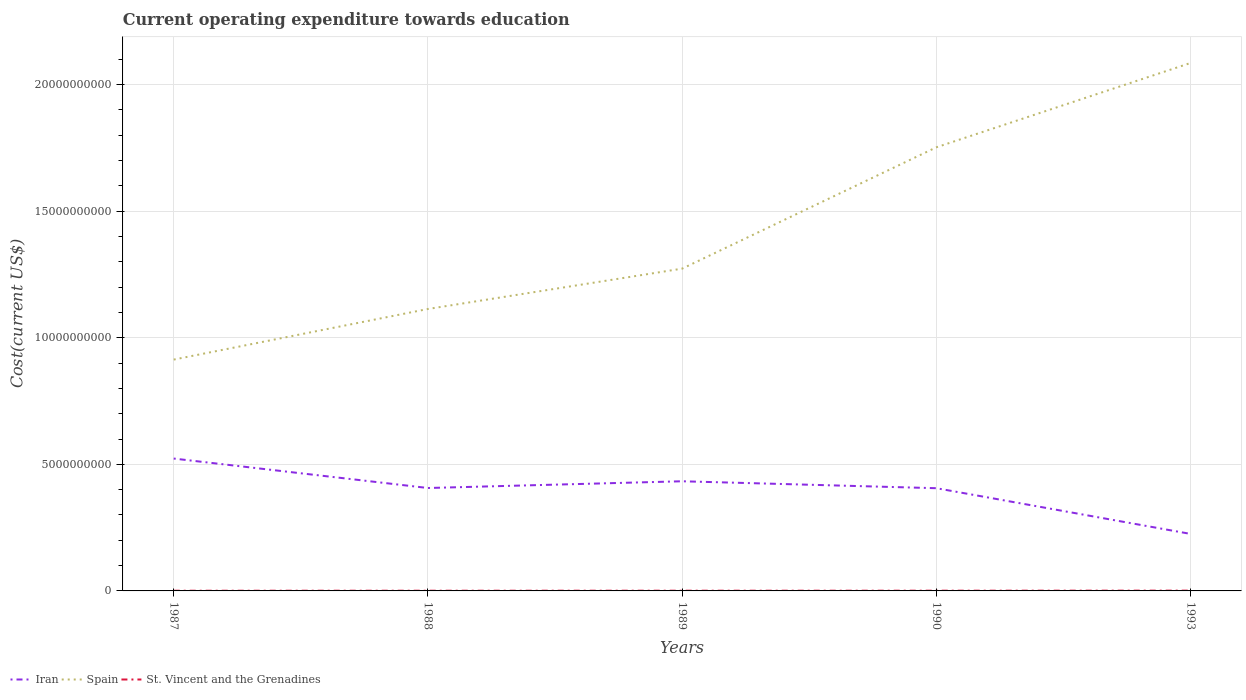How many different coloured lines are there?
Provide a short and direct response. 3. Does the line corresponding to Iran intersect with the line corresponding to St. Vincent and the Grenadines?
Provide a short and direct response. No. Across all years, what is the maximum expenditure towards education in Iran?
Provide a short and direct response. 2.25e+09. What is the total expenditure towards education in Spain in the graph?
Your answer should be compact. -4.79e+09. What is the difference between the highest and the second highest expenditure towards education in St. Vincent and the Grenadines?
Make the answer very short. 3.82e+06. What is the difference between the highest and the lowest expenditure towards education in Spain?
Your answer should be compact. 2. How many lines are there?
Offer a very short reply. 3. How many years are there in the graph?
Give a very brief answer. 5. Are the values on the major ticks of Y-axis written in scientific E-notation?
Offer a terse response. No. Does the graph contain grids?
Your response must be concise. Yes. How many legend labels are there?
Ensure brevity in your answer.  3. How are the legend labels stacked?
Make the answer very short. Horizontal. What is the title of the graph?
Give a very brief answer. Current operating expenditure towards education. Does "Korea (Democratic)" appear as one of the legend labels in the graph?
Offer a terse response. No. What is the label or title of the X-axis?
Ensure brevity in your answer.  Years. What is the label or title of the Y-axis?
Your response must be concise. Cost(current US$). What is the Cost(current US$) of Iran in 1987?
Your answer should be very brief. 5.23e+09. What is the Cost(current US$) of Spain in 1987?
Make the answer very short. 9.14e+09. What is the Cost(current US$) in St. Vincent and the Grenadines in 1987?
Your response must be concise. 7.44e+06. What is the Cost(current US$) in Iran in 1988?
Your answer should be very brief. 4.07e+09. What is the Cost(current US$) of Spain in 1988?
Ensure brevity in your answer.  1.11e+1. What is the Cost(current US$) of St. Vincent and the Grenadines in 1988?
Offer a terse response. 8.13e+06. What is the Cost(current US$) in Iran in 1989?
Offer a terse response. 4.33e+09. What is the Cost(current US$) of Spain in 1989?
Your answer should be compact. 1.27e+1. What is the Cost(current US$) in St. Vincent and the Grenadines in 1989?
Keep it short and to the point. 8.53e+06. What is the Cost(current US$) of Iran in 1990?
Your response must be concise. 4.06e+09. What is the Cost(current US$) of Spain in 1990?
Your response must be concise. 1.75e+1. What is the Cost(current US$) in St. Vincent and the Grenadines in 1990?
Make the answer very short. 8.99e+06. What is the Cost(current US$) in Iran in 1993?
Make the answer very short. 2.25e+09. What is the Cost(current US$) of Spain in 1993?
Ensure brevity in your answer.  2.09e+1. What is the Cost(current US$) of St. Vincent and the Grenadines in 1993?
Ensure brevity in your answer.  1.13e+07. Across all years, what is the maximum Cost(current US$) in Iran?
Provide a short and direct response. 5.23e+09. Across all years, what is the maximum Cost(current US$) in Spain?
Offer a very short reply. 2.09e+1. Across all years, what is the maximum Cost(current US$) in St. Vincent and the Grenadines?
Give a very brief answer. 1.13e+07. Across all years, what is the minimum Cost(current US$) of Iran?
Offer a terse response. 2.25e+09. Across all years, what is the minimum Cost(current US$) in Spain?
Provide a succinct answer. 9.14e+09. Across all years, what is the minimum Cost(current US$) of St. Vincent and the Grenadines?
Ensure brevity in your answer.  7.44e+06. What is the total Cost(current US$) in Iran in the graph?
Ensure brevity in your answer.  1.99e+1. What is the total Cost(current US$) in Spain in the graph?
Keep it short and to the point. 7.14e+1. What is the total Cost(current US$) in St. Vincent and the Grenadines in the graph?
Make the answer very short. 4.43e+07. What is the difference between the Cost(current US$) in Iran in 1987 and that in 1988?
Your answer should be compact. 1.16e+09. What is the difference between the Cost(current US$) in Spain in 1987 and that in 1988?
Keep it short and to the point. -2.00e+09. What is the difference between the Cost(current US$) in St. Vincent and the Grenadines in 1987 and that in 1988?
Make the answer very short. -6.94e+05. What is the difference between the Cost(current US$) of Iran in 1987 and that in 1989?
Keep it short and to the point. 8.97e+08. What is the difference between the Cost(current US$) in Spain in 1987 and that in 1989?
Your answer should be compact. -3.59e+09. What is the difference between the Cost(current US$) of St. Vincent and the Grenadines in 1987 and that in 1989?
Your response must be concise. -1.09e+06. What is the difference between the Cost(current US$) in Iran in 1987 and that in 1990?
Keep it short and to the point. 1.17e+09. What is the difference between the Cost(current US$) in Spain in 1987 and that in 1990?
Ensure brevity in your answer.  -8.39e+09. What is the difference between the Cost(current US$) of St. Vincent and the Grenadines in 1987 and that in 1990?
Your response must be concise. -1.55e+06. What is the difference between the Cost(current US$) of Iran in 1987 and that in 1993?
Offer a terse response. 2.98e+09. What is the difference between the Cost(current US$) of Spain in 1987 and that in 1993?
Ensure brevity in your answer.  -1.17e+1. What is the difference between the Cost(current US$) of St. Vincent and the Grenadines in 1987 and that in 1993?
Make the answer very short. -3.82e+06. What is the difference between the Cost(current US$) in Iran in 1988 and that in 1989?
Your response must be concise. -2.66e+08. What is the difference between the Cost(current US$) in Spain in 1988 and that in 1989?
Your answer should be compact. -1.59e+09. What is the difference between the Cost(current US$) in St. Vincent and the Grenadines in 1988 and that in 1989?
Offer a terse response. -3.98e+05. What is the difference between the Cost(current US$) of Iran in 1988 and that in 1990?
Offer a very short reply. 8.02e+06. What is the difference between the Cost(current US$) of Spain in 1988 and that in 1990?
Keep it short and to the point. -6.39e+09. What is the difference between the Cost(current US$) in St. Vincent and the Grenadines in 1988 and that in 1990?
Your answer should be very brief. -8.57e+05. What is the difference between the Cost(current US$) of Iran in 1988 and that in 1993?
Offer a terse response. 1.81e+09. What is the difference between the Cost(current US$) in Spain in 1988 and that in 1993?
Keep it short and to the point. -9.72e+09. What is the difference between the Cost(current US$) of St. Vincent and the Grenadines in 1988 and that in 1993?
Provide a succinct answer. -3.13e+06. What is the difference between the Cost(current US$) in Iran in 1989 and that in 1990?
Provide a succinct answer. 2.74e+08. What is the difference between the Cost(current US$) in Spain in 1989 and that in 1990?
Ensure brevity in your answer.  -4.79e+09. What is the difference between the Cost(current US$) in St. Vincent and the Grenadines in 1989 and that in 1990?
Your answer should be very brief. -4.59e+05. What is the difference between the Cost(current US$) of Iran in 1989 and that in 1993?
Ensure brevity in your answer.  2.08e+09. What is the difference between the Cost(current US$) of Spain in 1989 and that in 1993?
Give a very brief answer. -8.12e+09. What is the difference between the Cost(current US$) of St. Vincent and the Grenadines in 1989 and that in 1993?
Your response must be concise. -2.73e+06. What is the difference between the Cost(current US$) in Iran in 1990 and that in 1993?
Your response must be concise. 1.81e+09. What is the difference between the Cost(current US$) of Spain in 1990 and that in 1993?
Ensure brevity in your answer.  -3.33e+09. What is the difference between the Cost(current US$) of St. Vincent and the Grenadines in 1990 and that in 1993?
Offer a very short reply. -2.27e+06. What is the difference between the Cost(current US$) of Iran in 1987 and the Cost(current US$) of Spain in 1988?
Provide a short and direct response. -5.91e+09. What is the difference between the Cost(current US$) of Iran in 1987 and the Cost(current US$) of St. Vincent and the Grenadines in 1988?
Ensure brevity in your answer.  5.22e+09. What is the difference between the Cost(current US$) of Spain in 1987 and the Cost(current US$) of St. Vincent and the Grenadines in 1988?
Provide a succinct answer. 9.13e+09. What is the difference between the Cost(current US$) of Iran in 1987 and the Cost(current US$) of Spain in 1989?
Keep it short and to the point. -7.50e+09. What is the difference between the Cost(current US$) in Iran in 1987 and the Cost(current US$) in St. Vincent and the Grenadines in 1989?
Keep it short and to the point. 5.22e+09. What is the difference between the Cost(current US$) of Spain in 1987 and the Cost(current US$) of St. Vincent and the Grenadines in 1989?
Offer a very short reply. 9.13e+09. What is the difference between the Cost(current US$) of Iran in 1987 and the Cost(current US$) of Spain in 1990?
Ensure brevity in your answer.  -1.23e+1. What is the difference between the Cost(current US$) in Iran in 1987 and the Cost(current US$) in St. Vincent and the Grenadines in 1990?
Your response must be concise. 5.22e+09. What is the difference between the Cost(current US$) in Spain in 1987 and the Cost(current US$) in St. Vincent and the Grenadines in 1990?
Your answer should be very brief. 9.13e+09. What is the difference between the Cost(current US$) in Iran in 1987 and the Cost(current US$) in Spain in 1993?
Your answer should be very brief. -1.56e+1. What is the difference between the Cost(current US$) in Iran in 1987 and the Cost(current US$) in St. Vincent and the Grenadines in 1993?
Your answer should be compact. 5.22e+09. What is the difference between the Cost(current US$) in Spain in 1987 and the Cost(current US$) in St. Vincent and the Grenadines in 1993?
Provide a short and direct response. 9.13e+09. What is the difference between the Cost(current US$) of Iran in 1988 and the Cost(current US$) of Spain in 1989?
Provide a succinct answer. -8.67e+09. What is the difference between the Cost(current US$) in Iran in 1988 and the Cost(current US$) in St. Vincent and the Grenadines in 1989?
Provide a short and direct response. 4.06e+09. What is the difference between the Cost(current US$) of Spain in 1988 and the Cost(current US$) of St. Vincent and the Grenadines in 1989?
Make the answer very short. 1.11e+1. What is the difference between the Cost(current US$) in Iran in 1988 and the Cost(current US$) in Spain in 1990?
Keep it short and to the point. -1.35e+1. What is the difference between the Cost(current US$) of Iran in 1988 and the Cost(current US$) of St. Vincent and the Grenadines in 1990?
Your answer should be very brief. 4.06e+09. What is the difference between the Cost(current US$) of Spain in 1988 and the Cost(current US$) of St. Vincent and the Grenadines in 1990?
Ensure brevity in your answer.  1.11e+1. What is the difference between the Cost(current US$) of Iran in 1988 and the Cost(current US$) of Spain in 1993?
Offer a very short reply. -1.68e+1. What is the difference between the Cost(current US$) in Iran in 1988 and the Cost(current US$) in St. Vincent and the Grenadines in 1993?
Offer a very short reply. 4.05e+09. What is the difference between the Cost(current US$) of Spain in 1988 and the Cost(current US$) of St. Vincent and the Grenadines in 1993?
Your response must be concise. 1.11e+1. What is the difference between the Cost(current US$) of Iran in 1989 and the Cost(current US$) of Spain in 1990?
Your response must be concise. -1.32e+1. What is the difference between the Cost(current US$) in Iran in 1989 and the Cost(current US$) in St. Vincent and the Grenadines in 1990?
Provide a succinct answer. 4.32e+09. What is the difference between the Cost(current US$) in Spain in 1989 and the Cost(current US$) in St. Vincent and the Grenadines in 1990?
Your answer should be very brief. 1.27e+1. What is the difference between the Cost(current US$) of Iran in 1989 and the Cost(current US$) of Spain in 1993?
Offer a terse response. -1.65e+1. What is the difference between the Cost(current US$) of Iran in 1989 and the Cost(current US$) of St. Vincent and the Grenadines in 1993?
Offer a very short reply. 4.32e+09. What is the difference between the Cost(current US$) of Spain in 1989 and the Cost(current US$) of St. Vincent and the Grenadines in 1993?
Your answer should be very brief. 1.27e+1. What is the difference between the Cost(current US$) in Iran in 1990 and the Cost(current US$) in Spain in 1993?
Offer a very short reply. -1.68e+1. What is the difference between the Cost(current US$) in Iran in 1990 and the Cost(current US$) in St. Vincent and the Grenadines in 1993?
Give a very brief answer. 4.05e+09. What is the difference between the Cost(current US$) of Spain in 1990 and the Cost(current US$) of St. Vincent and the Grenadines in 1993?
Give a very brief answer. 1.75e+1. What is the average Cost(current US$) in Iran per year?
Offer a terse response. 3.99e+09. What is the average Cost(current US$) in Spain per year?
Give a very brief answer. 1.43e+1. What is the average Cost(current US$) of St. Vincent and the Grenadines per year?
Your response must be concise. 8.87e+06. In the year 1987, what is the difference between the Cost(current US$) in Iran and Cost(current US$) in Spain?
Your response must be concise. -3.91e+09. In the year 1987, what is the difference between the Cost(current US$) in Iran and Cost(current US$) in St. Vincent and the Grenadines?
Offer a terse response. 5.22e+09. In the year 1987, what is the difference between the Cost(current US$) of Spain and Cost(current US$) of St. Vincent and the Grenadines?
Your answer should be very brief. 9.13e+09. In the year 1988, what is the difference between the Cost(current US$) of Iran and Cost(current US$) of Spain?
Provide a short and direct response. -7.07e+09. In the year 1988, what is the difference between the Cost(current US$) in Iran and Cost(current US$) in St. Vincent and the Grenadines?
Ensure brevity in your answer.  4.06e+09. In the year 1988, what is the difference between the Cost(current US$) of Spain and Cost(current US$) of St. Vincent and the Grenadines?
Make the answer very short. 1.11e+1. In the year 1989, what is the difference between the Cost(current US$) in Iran and Cost(current US$) in Spain?
Keep it short and to the point. -8.40e+09. In the year 1989, what is the difference between the Cost(current US$) of Iran and Cost(current US$) of St. Vincent and the Grenadines?
Your response must be concise. 4.32e+09. In the year 1989, what is the difference between the Cost(current US$) in Spain and Cost(current US$) in St. Vincent and the Grenadines?
Your answer should be very brief. 1.27e+1. In the year 1990, what is the difference between the Cost(current US$) in Iran and Cost(current US$) in Spain?
Provide a short and direct response. -1.35e+1. In the year 1990, what is the difference between the Cost(current US$) in Iran and Cost(current US$) in St. Vincent and the Grenadines?
Provide a short and direct response. 4.05e+09. In the year 1990, what is the difference between the Cost(current US$) of Spain and Cost(current US$) of St. Vincent and the Grenadines?
Make the answer very short. 1.75e+1. In the year 1993, what is the difference between the Cost(current US$) of Iran and Cost(current US$) of Spain?
Your response must be concise. -1.86e+1. In the year 1993, what is the difference between the Cost(current US$) of Iran and Cost(current US$) of St. Vincent and the Grenadines?
Give a very brief answer. 2.24e+09. In the year 1993, what is the difference between the Cost(current US$) in Spain and Cost(current US$) in St. Vincent and the Grenadines?
Provide a short and direct response. 2.08e+1. What is the ratio of the Cost(current US$) in Iran in 1987 to that in 1988?
Ensure brevity in your answer.  1.29. What is the ratio of the Cost(current US$) of Spain in 1987 to that in 1988?
Keep it short and to the point. 0.82. What is the ratio of the Cost(current US$) in St. Vincent and the Grenadines in 1987 to that in 1988?
Provide a short and direct response. 0.91. What is the ratio of the Cost(current US$) of Iran in 1987 to that in 1989?
Provide a short and direct response. 1.21. What is the ratio of the Cost(current US$) of Spain in 1987 to that in 1989?
Keep it short and to the point. 0.72. What is the ratio of the Cost(current US$) in St. Vincent and the Grenadines in 1987 to that in 1989?
Your answer should be very brief. 0.87. What is the ratio of the Cost(current US$) of Iran in 1987 to that in 1990?
Keep it short and to the point. 1.29. What is the ratio of the Cost(current US$) of Spain in 1987 to that in 1990?
Provide a succinct answer. 0.52. What is the ratio of the Cost(current US$) in St. Vincent and the Grenadines in 1987 to that in 1990?
Provide a short and direct response. 0.83. What is the ratio of the Cost(current US$) in Iran in 1987 to that in 1993?
Give a very brief answer. 2.32. What is the ratio of the Cost(current US$) of Spain in 1987 to that in 1993?
Keep it short and to the point. 0.44. What is the ratio of the Cost(current US$) of St. Vincent and the Grenadines in 1987 to that in 1993?
Provide a succinct answer. 0.66. What is the ratio of the Cost(current US$) of Iran in 1988 to that in 1989?
Offer a very short reply. 0.94. What is the ratio of the Cost(current US$) in Spain in 1988 to that in 1989?
Give a very brief answer. 0.87. What is the ratio of the Cost(current US$) of St. Vincent and the Grenadines in 1988 to that in 1989?
Provide a short and direct response. 0.95. What is the ratio of the Cost(current US$) in Iran in 1988 to that in 1990?
Ensure brevity in your answer.  1. What is the ratio of the Cost(current US$) in Spain in 1988 to that in 1990?
Make the answer very short. 0.64. What is the ratio of the Cost(current US$) of St. Vincent and the Grenadines in 1988 to that in 1990?
Your answer should be compact. 0.9. What is the ratio of the Cost(current US$) of Iran in 1988 to that in 1993?
Your answer should be compact. 1.81. What is the ratio of the Cost(current US$) of Spain in 1988 to that in 1993?
Your answer should be compact. 0.53. What is the ratio of the Cost(current US$) of St. Vincent and the Grenadines in 1988 to that in 1993?
Make the answer very short. 0.72. What is the ratio of the Cost(current US$) in Iran in 1989 to that in 1990?
Provide a short and direct response. 1.07. What is the ratio of the Cost(current US$) of Spain in 1989 to that in 1990?
Offer a terse response. 0.73. What is the ratio of the Cost(current US$) of St. Vincent and the Grenadines in 1989 to that in 1990?
Give a very brief answer. 0.95. What is the ratio of the Cost(current US$) in Iran in 1989 to that in 1993?
Provide a succinct answer. 1.92. What is the ratio of the Cost(current US$) of Spain in 1989 to that in 1993?
Offer a very short reply. 0.61. What is the ratio of the Cost(current US$) in St. Vincent and the Grenadines in 1989 to that in 1993?
Provide a succinct answer. 0.76. What is the ratio of the Cost(current US$) of Iran in 1990 to that in 1993?
Give a very brief answer. 1.8. What is the ratio of the Cost(current US$) of Spain in 1990 to that in 1993?
Give a very brief answer. 0.84. What is the ratio of the Cost(current US$) of St. Vincent and the Grenadines in 1990 to that in 1993?
Ensure brevity in your answer.  0.8. What is the difference between the highest and the second highest Cost(current US$) of Iran?
Give a very brief answer. 8.97e+08. What is the difference between the highest and the second highest Cost(current US$) in Spain?
Offer a very short reply. 3.33e+09. What is the difference between the highest and the second highest Cost(current US$) in St. Vincent and the Grenadines?
Offer a terse response. 2.27e+06. What is the difference between the highest and the lowest Cost(current US$) of Iran?
Provide a short and direct response. 2.98e+09. What is the difference between the highest and the lowest Cost(current US$) in Spain?
Ensure brevity in your answer.  1.17e+1. What is the difference between the highest and the lowest Cost(current US$) in St. Vincent and the Grenadines?
Offer a terse response. 3.82e+06. 